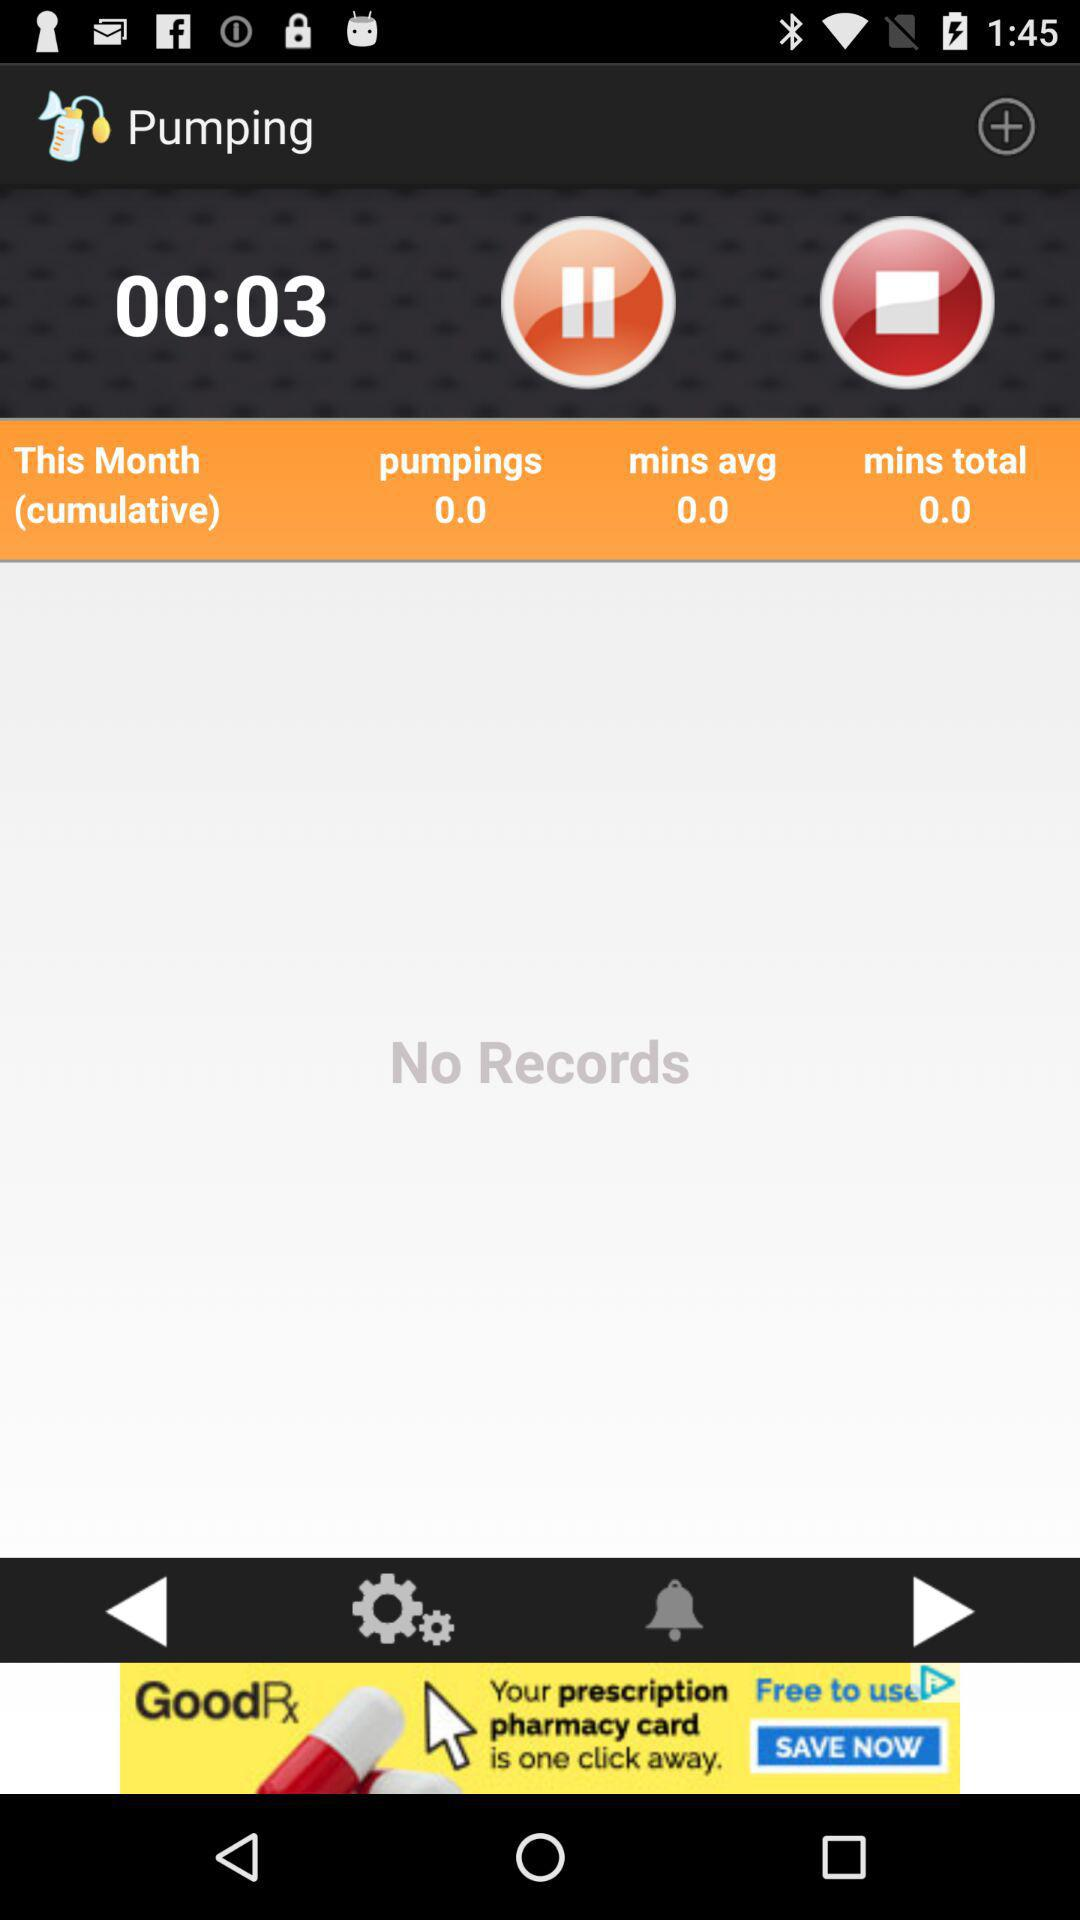How many seconds are there? There are 3 seconds. 